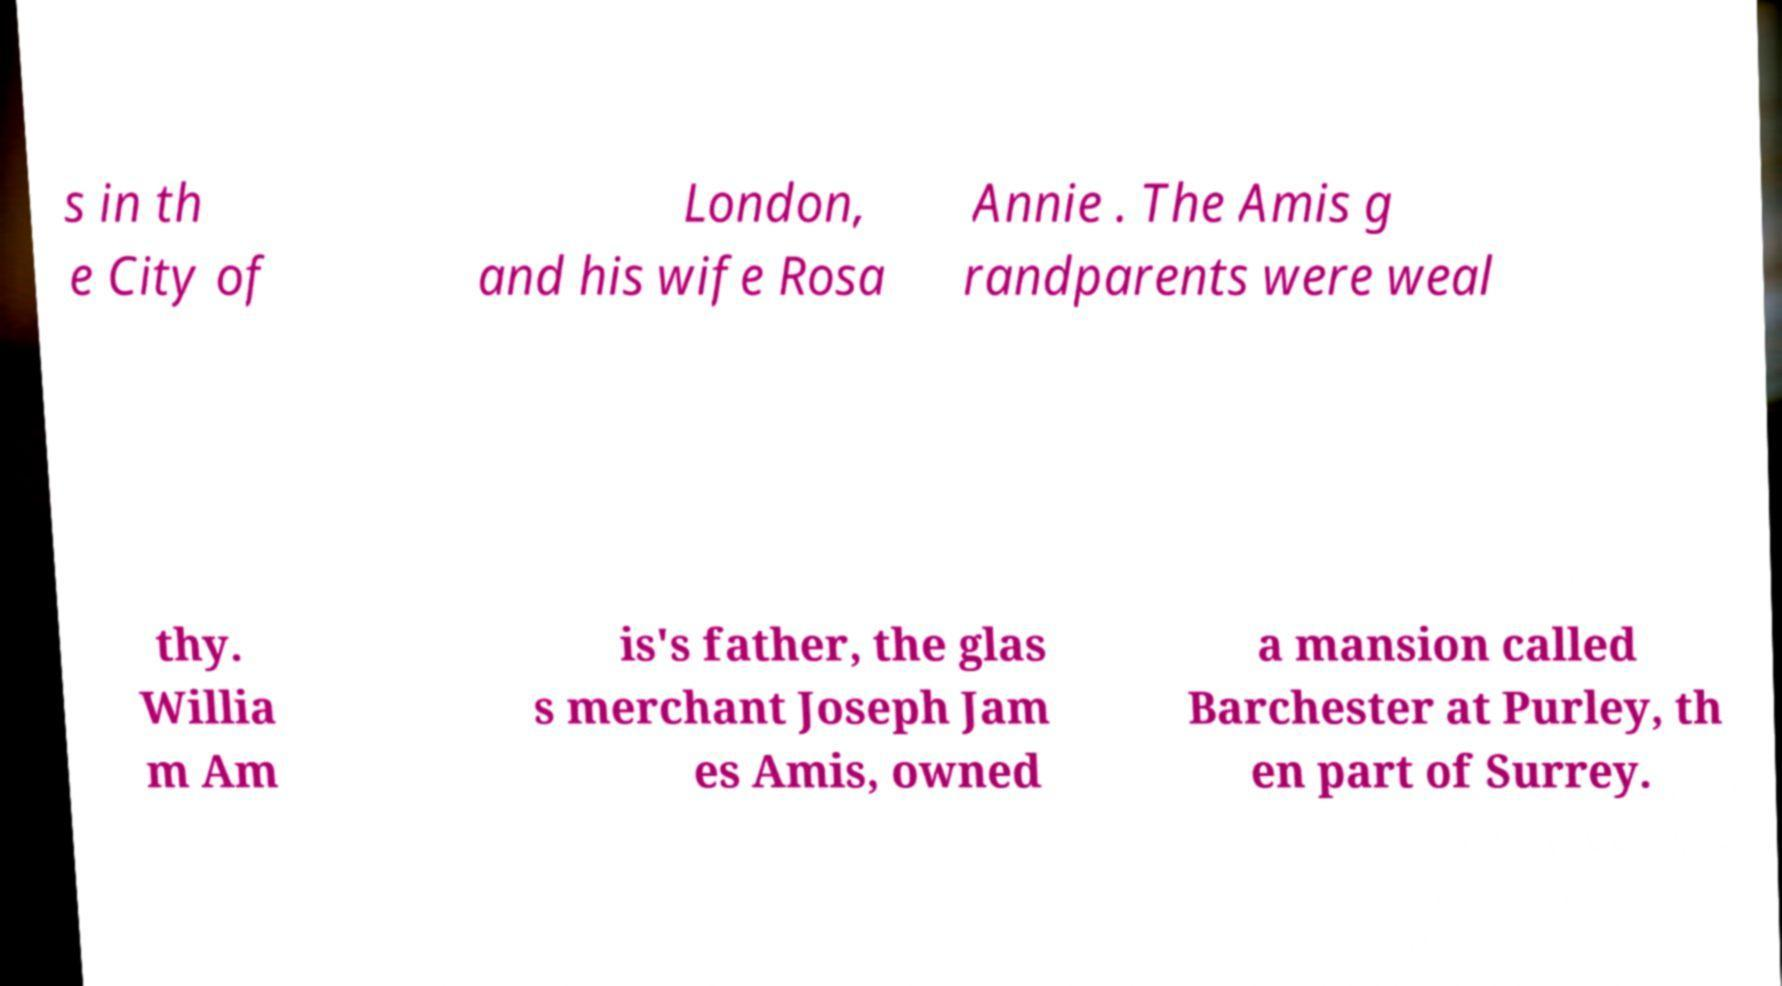Could you extract and type out the text from this image? s in th e City of London, and his wife Rosa Annie . The Amis g randparents were weal thy. Willia m Am is's father, the glas s merchant Joseph Jam es Amis, owned a mansion called Barchester at Purley, th en part of Surrey. 